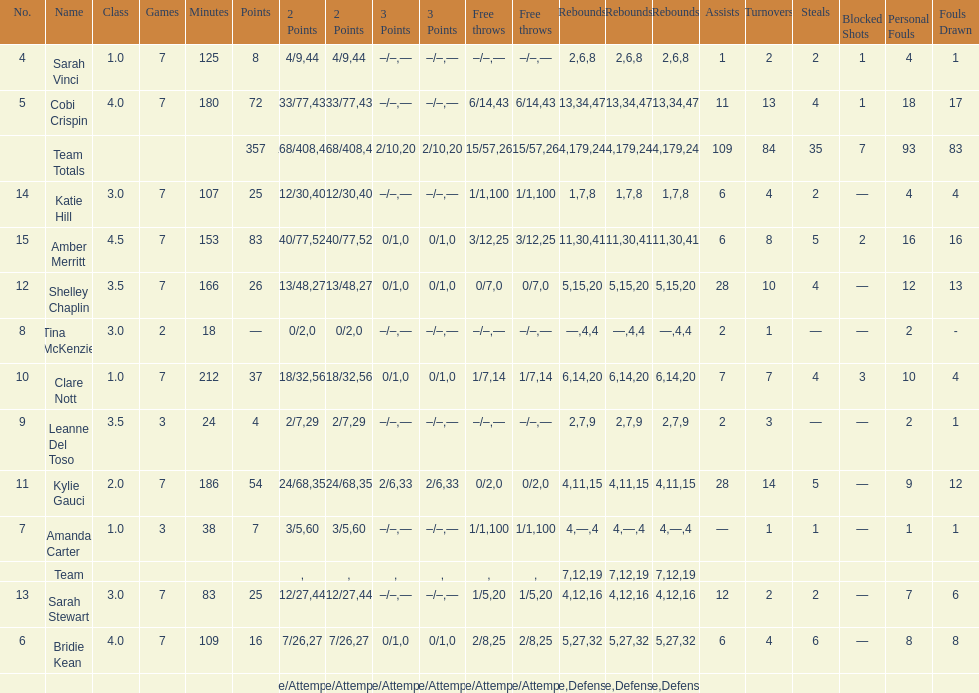Which player played in the least games? Tina McKenzie. Could you parse the entire table as a dict? {'header': ['No.', 'Name', 'Class', 'Games', 'Minutes', 'Points', '2 Points', '2 Points', '3 Points', '3 Points', 'Free throws', 'Free throws', 'Rebounds', 'Rebounds', 'Rebounds', 'Assists', 'Turnovers', 'Steals', 'Blocked Shots', 'Personal Fouls', 'Fouls Drawn'], 'rows': [['4', 'Sarah Vinci', '1.0', '7', '125', '8', '4/9', '44', '–/–', '—', '–/–', '—', '2', '6', '8', '1', '2', '2', '1', '4', '1'], ['5', 'Cobi Crispin', '4.0', '7', '180', '72', '33/77', '43', '–/–', '—', '6/14', '43', '13', '34', '47', '11', '13', '4', '1', '18', '17'], ['', 'Team Totals', '', '', '', '357', '168/408', '41', '2/10', '20', '15/57', '26', '64', '179', '243', '109', '84', '35', '7', '93', '83'], ['14', 'Katie Hill', '3.0', '7', '107', '25', '12/30', '40', '–/–', '—', '1/1', '100', '1', '7', '8', '6', '4', '2', '—', '4', '4'], ['15', 'Amber Merritt', '4.5', '7', '153', '83', '40/77', '52', '0/1', '0', '3/12', '25', '11', '30', '41', '6', '8', '5', '2', '16', '16'], ['12', 'Shelley Chaplin', '3.5', '7', '166', '26', '13/48', '27', '0/1', '0', '0/7', '0', '5', '15', '20', '28', '10', '4', '—', '12', '13'], ['8', 'Tina McKenzie', '3.0', '2', '18', '—', '0/2', '0', '–/–', '—', '–/–', '—', '—', '4', '4', '2', '1', '—', '—', '2', '-'], ['10', 'Clare Nott', '1.0', '7', '212', '37', '18/32', '56', '0/1', '0', '1/7', '14', '6', '14', '20', '7', '7', '4', '3', '10', '4'], ['9', 'Leanne Del Toso', '3.5', '3', '24', '4', '2/7', '29', '–/–', '—', '–/–', '—', '2', '7', '9', '2', '3', '—', '—', '2', '1'], ['11', 'Kylie Gauci', '2.0', '7', '186', '54', '24/68', '35', '2/6', '33', '0/2', '0', '4', '11', '15', '28', '14', '5', '—', '9', '12'], ['7', 'Amanda Carter', '1.0', '3', '38', '7', '3/5', '60', '–/–', '—', '1/1', '100', '4', '—', '4', '—', '1', '1', '—', '1', '1'], ['', 'Team', '', '', '', '', '', '', '', '', '', '', '7', '12', '19', '', '', '', '', '', ''], ['13', 'Sarah Stewart', '3.0', '7', '83', '25', '12/27', '44', '–/–', '—', '1/5', '20', '4', '12', '16', '12', '2', '2', '—', '7', '6'], ['6', 'Bridie Kean', '4.0', '7', '109', '16', '7/26', '27', '0/1', '0', '2/8', '25', '5', '27', '32', '6', '4', '6', '—', '8', '8'], ['', '', '', '', '', '', 'Made/Attempts', '%', 'Made/Attempts', '%', 'Made/Attempts', '%', 'Offensive', 'Defensive', 'Total', '', '', '', '', '', '']]} 